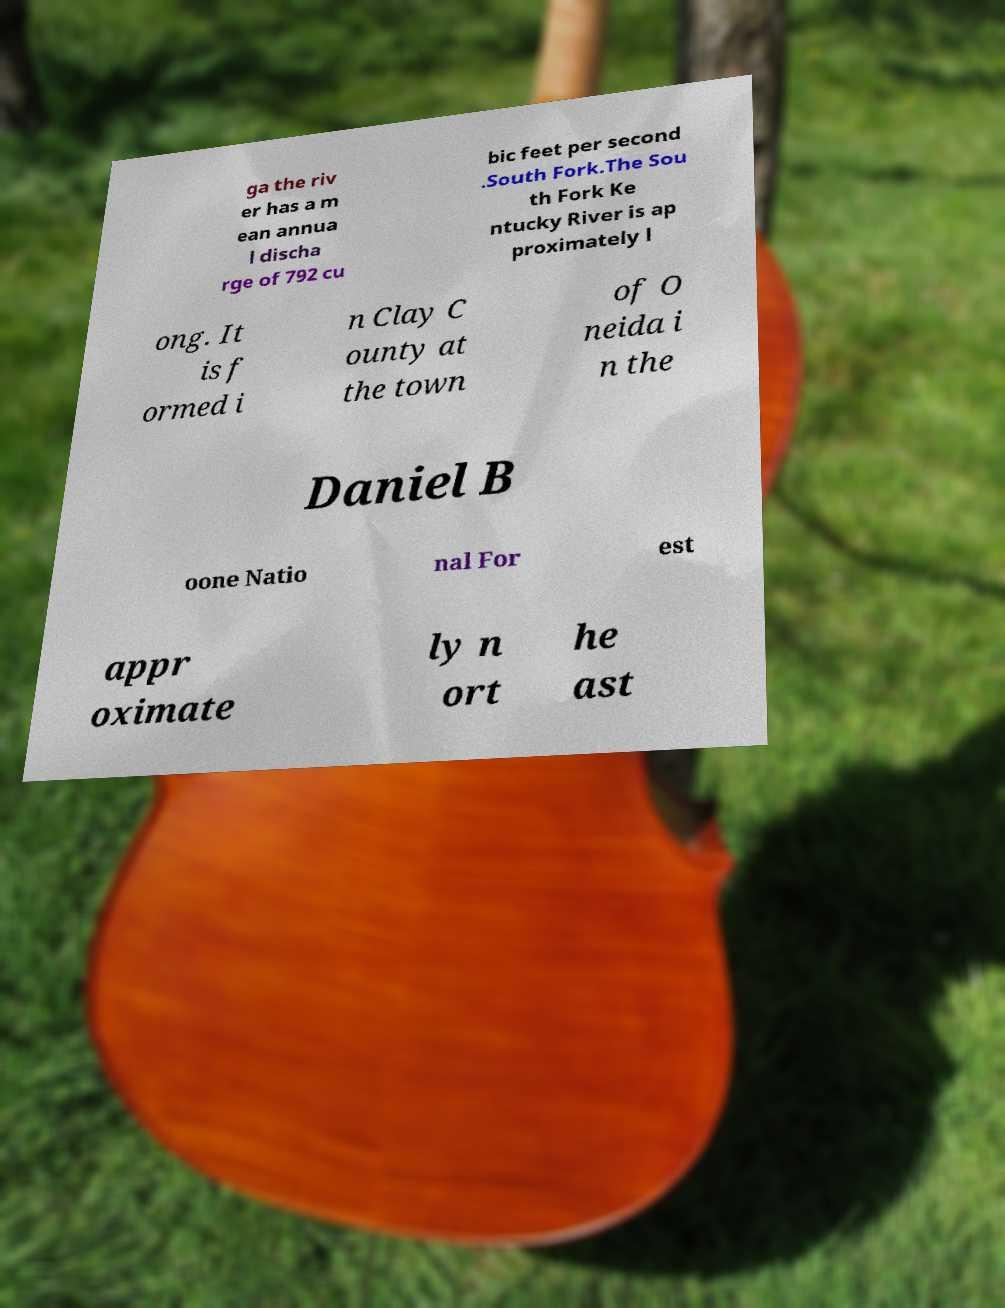What messages or text are displayed in this image? I need them in a readable, typed format. ga the riv er has a m ean annua l discha rge of 792 cu bic feet per second .South Fork.The Sou th Fork Ke ntucky River is ap proximately l ong. It is f ormed i n Clay C ounty at the town of O neida i n the Daniel B oone Natio nal For est appr oximate ly n ort he ast 